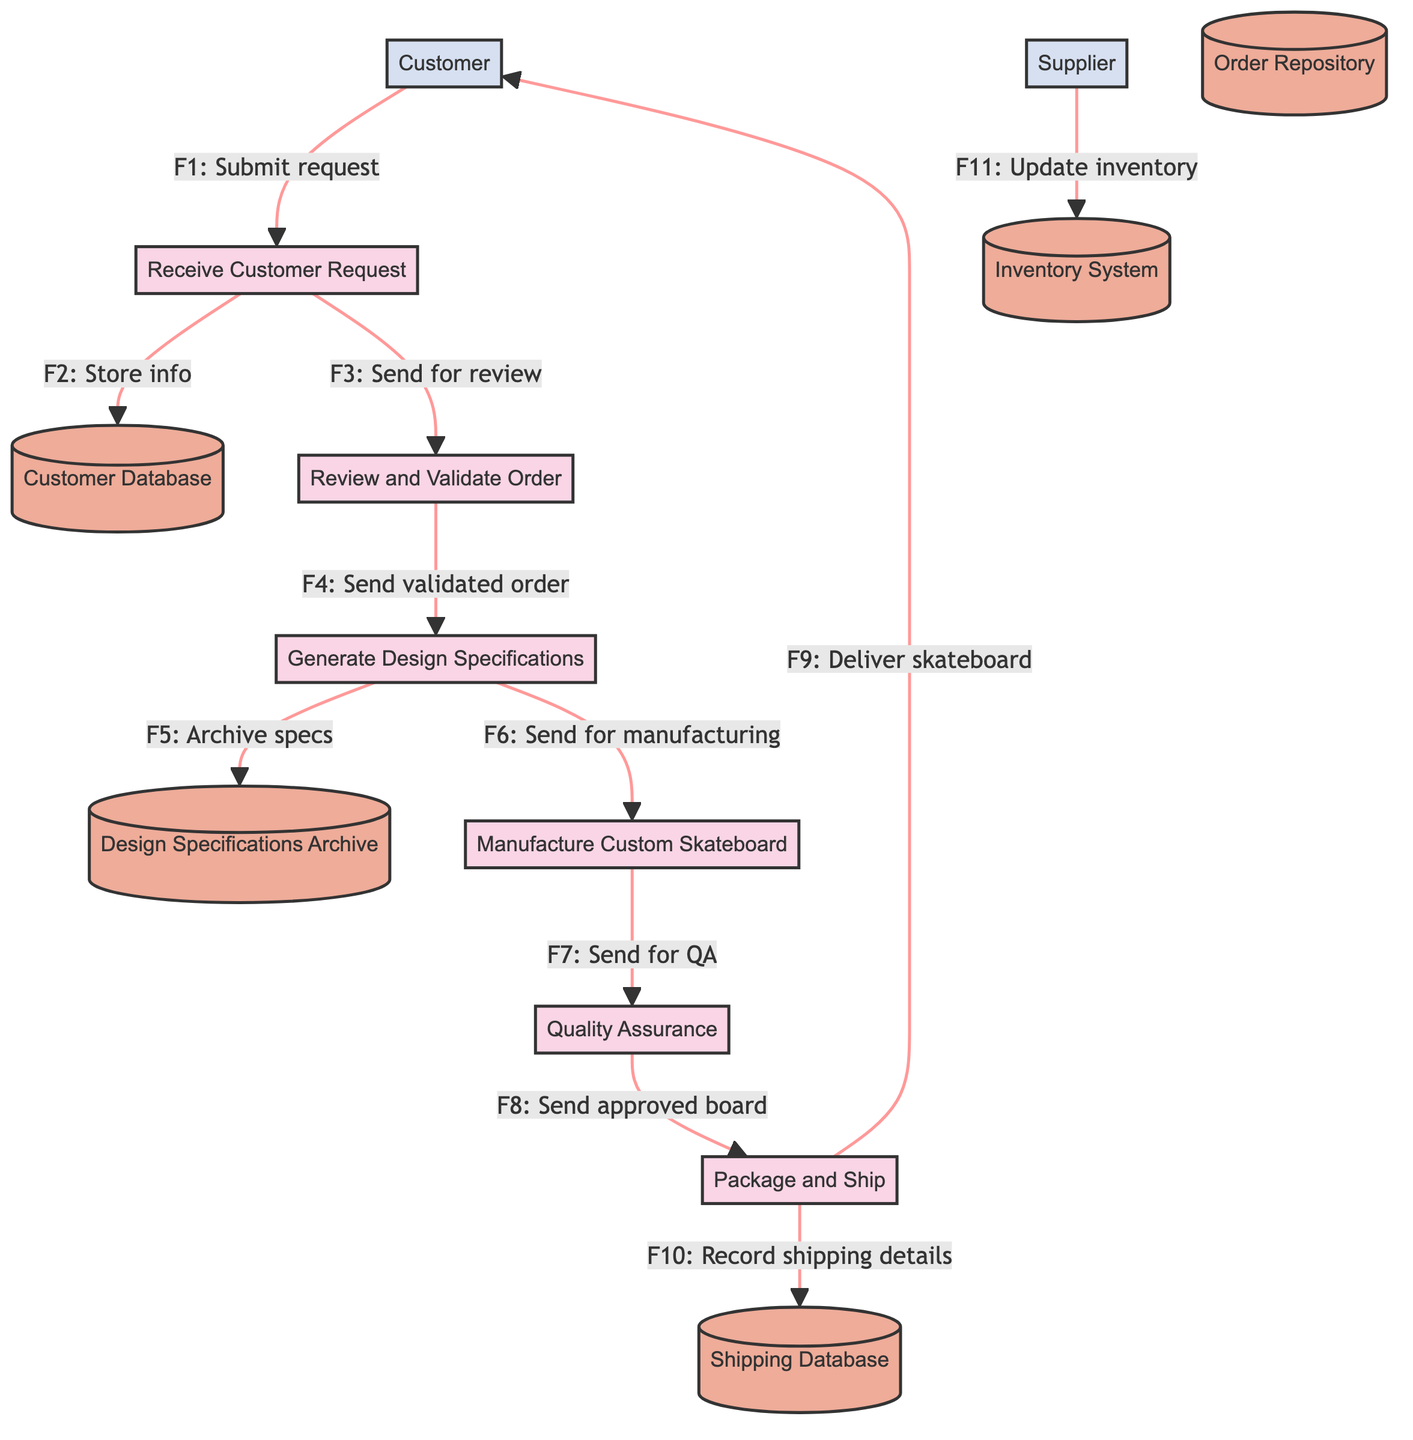What is the first process in the flow? The flow starts with the "Receive Customer Request" process (P1), which is the first step where customer requests are handled.
Answer: Receive Customer Request How many data stores are there in total? There are five data stores shown in the diagram: Customer Database, Order Repository, Design Specifications Archive, Inventory System, and Shipping Database.
Answer: 5 What data flow occurs from the "Manufacture Custom Skateboard" process? After the "Manufacture Custom Skateboard" process (P4), the data flow goes to "Quality Assurance" (P5) indicating the skateboard is sent for inspection.
Answer: Quality Assurance What happens to the completed skateboard after quality assurance? The completed skateboard is sent to the "Package and Ship" process (P6) for packaging and delivery after passing the quality assurance stage.
Answer: Package and Ship Which external entity updates the inventory system? The "Supplier" (E2) provides inventory status updates to the "Inventory System" (D4), ensuring the materials are tracked correctly.
Answer: Supplier What is the final destination of the skateboard in the flow? The final destination for the skateboard is the "Customer" (E1), where the skateboard is delivered after packaging.
Answer: Customer How many processes are involved in the customization order processing system? There are six processes in the diagram, each contributing to the order processing from request to delivery.
Answer: 6 What type of information is stored in the Customer Database? The "Customer Database" (D1) stores customer information and order history, which is crucial for managing ongoing relationships and future orders.
Answer: Customer information and order history What is the purpose of the "Quality Assurance" process? The "Quality Assurance" process (P5) inspects the skateboard to ensure it meets quality standards before it proceeds to shipping.
Answer: Inspects skateboard quality Which process generates design specifications? The process responsible for generating design specifications is the "Generate Design Specifications" (P3), based on customer preferences.
Answer: Generate Design Specifications 